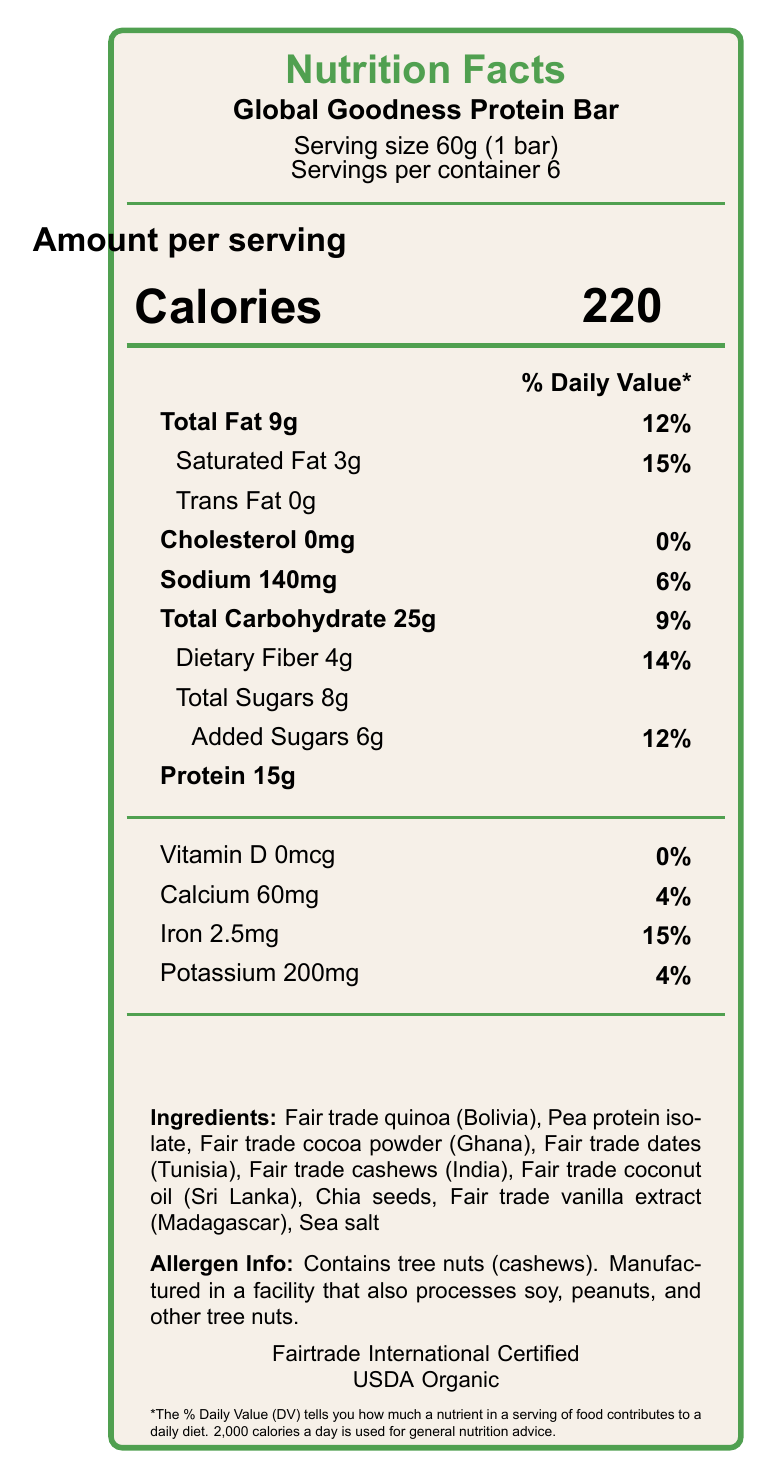what is the serving size of the Global Goodness Protein Bar? The serving size is specified as 60g, which equals 1 bar according to the information provided near the top of the document.
Answer: 60g (1 bar) how many servings are there per container? The document clearly states that there are 6 servings per container.
Answer: 6 how many calories are there per serving? The calories per serving are listed under the "Amount per serving" section as 220 calories.
Answer: 220 how much protein is in one serving of the protein bar? The amount of protein per serving is listed as 15g.
Answer: 15g what percentage of the daily value for saturated fat does one serving provide? The percentage of the daily value for saturated fat is indicated as 15%.
Answer: 15% what is the total fat content per serving? A. 3g B. 6g C. 9g D. 12g The total fat content per serving is listed as 9g, making option C correct.
Answer: C which ingredient in the protein bar comes from Ghana? A. Fair trade quinoa B. Fair trade dates C. Fair trade cocoa powder D. Fair trade cashews The document states that the fair trade cocoa powder is sourced from Ghana.
Answer: C are there any tree nuts in the protein bar? The allergen information specifies that the bar contains cashews, which are tree nuts.
Answer: Yes how much iron does one serving contain? The amount of iron per serving is listed as 2.5mg.
Answer: 2.5mg does the protein bar contain any cholesterol? The document lists cholesterol content as 0mg, indicating that it does not contain cholesterol.
Answer: No what certifications does the protein bar have? The document specifies that the protein bar is certified by Fairtrade International and USDA Organic.
Answer: Fairtrade International and USDA Organic what is the main idea of the Nutrition Facts Label for the Global Goodness Protein Bar? The document includes nutritional facts, ingredient sources from various developing countries, fair trade and organic certifications, and information about the product's sustainability and ethical sourcing.
Answer: The document provides detailed nutritional information, ingredient sources, certifications, and ethical statements for the Global Goodness Protein Bar, highlighting its fair trade and organic certifications and its contributions to sustainable agriculture and community development in developing countries. how much calcium and potassium are in one serving of this protein bar? The document lists the calcium content as 60mg and the potassium content as 200mg per serving.
Answer: Calcium: 60mg, Potassium: 200mg is the packaging of the protein bar environmentally friendly? The document mentions the packaging is 100% recyclable and made from plant-based materials.
Answer: Yes how much total carbohydrate is in one serving, and what percentage of the daily value does it represent? The total carbohydrate content is 25g per serving, which represents 9% of the daily value.
Answer: 25g, 9% can the exact number of calories from fat be determined from the information given in the document? The document provides total fat content and calories per serving but does not provide specific information on calories from fat, so the exact number cannot be determined.
Answer: Not enough information 